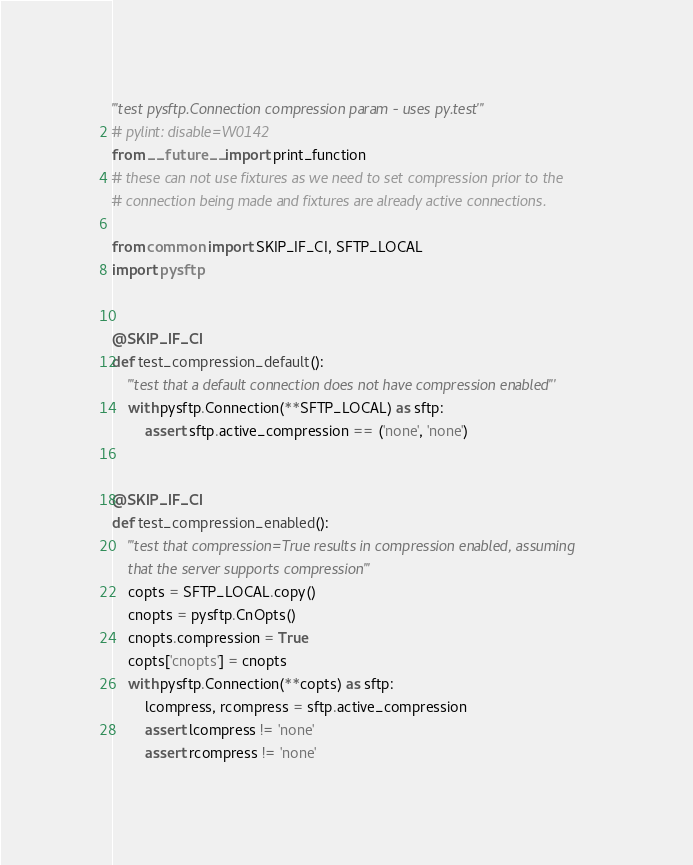<code> <loc_0><loc_0><loc_500><loc_500><_Python_>'''test pysftp.Connection compression param - uses py.test'''
# pylint: disable=W0142
from __future__ import print_function
# these can not use fixtures as we need to set compression prior to the
# connection being made and fixtures are already active connections.

from common import SKIP_IF_CI, SFTP_LOCAL
import pysftp


@SKIP_IF_CI
def test_compression_default():
    '''test that a default connection does not have compression enabled'''
    with pysftp.Connection(**SFTP_LOCAL) as sftp:
        assert sftp.active_compression == ('none', 'none')


@SKIP_IF_CI
def test_compression_enabled():
    '''test that compression=True results in compression enabled, assuming
    that the server supports compression'''
    copts = SFTP_LOCAL.copy()
    cnopts = pysftp.CnOpts()
    cnopts.compression = True
    copts['cnopts'] = cnopts
    with pysftp.Connection(**copts) as sftp:
        lcompress, rcompress = sftp.active_compression
        assert lcompress != 'none'
        assert rcompress != 'none'
</code> 